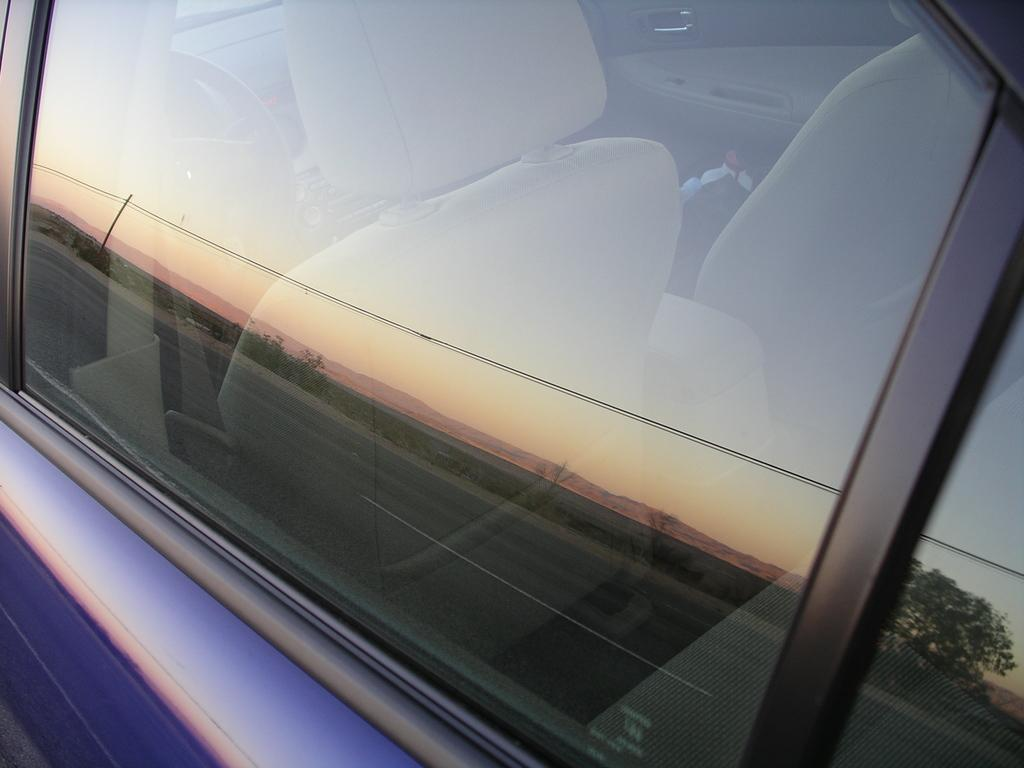What is the main subject of the picture? The main subject of the picture is a car. What features are present in the car? The car has seats and a steering wheel. Where is the playground located in the image? There is no playground present in the image; it features a car with seats and a steering wheel. What type of land can be seen in the image? The image does not show any specific type of land; it only features a car. 